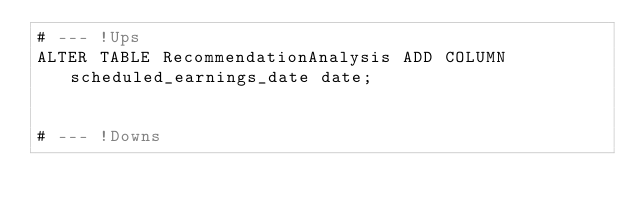<code> <loc_0><loc_0><loc_500><loc_500><_SQL_># --- !Ups
ALTER TABLE RecommendationAnalysis ADD COLUMN scheduled_earnings_date date;


# --- !Downs</code> 